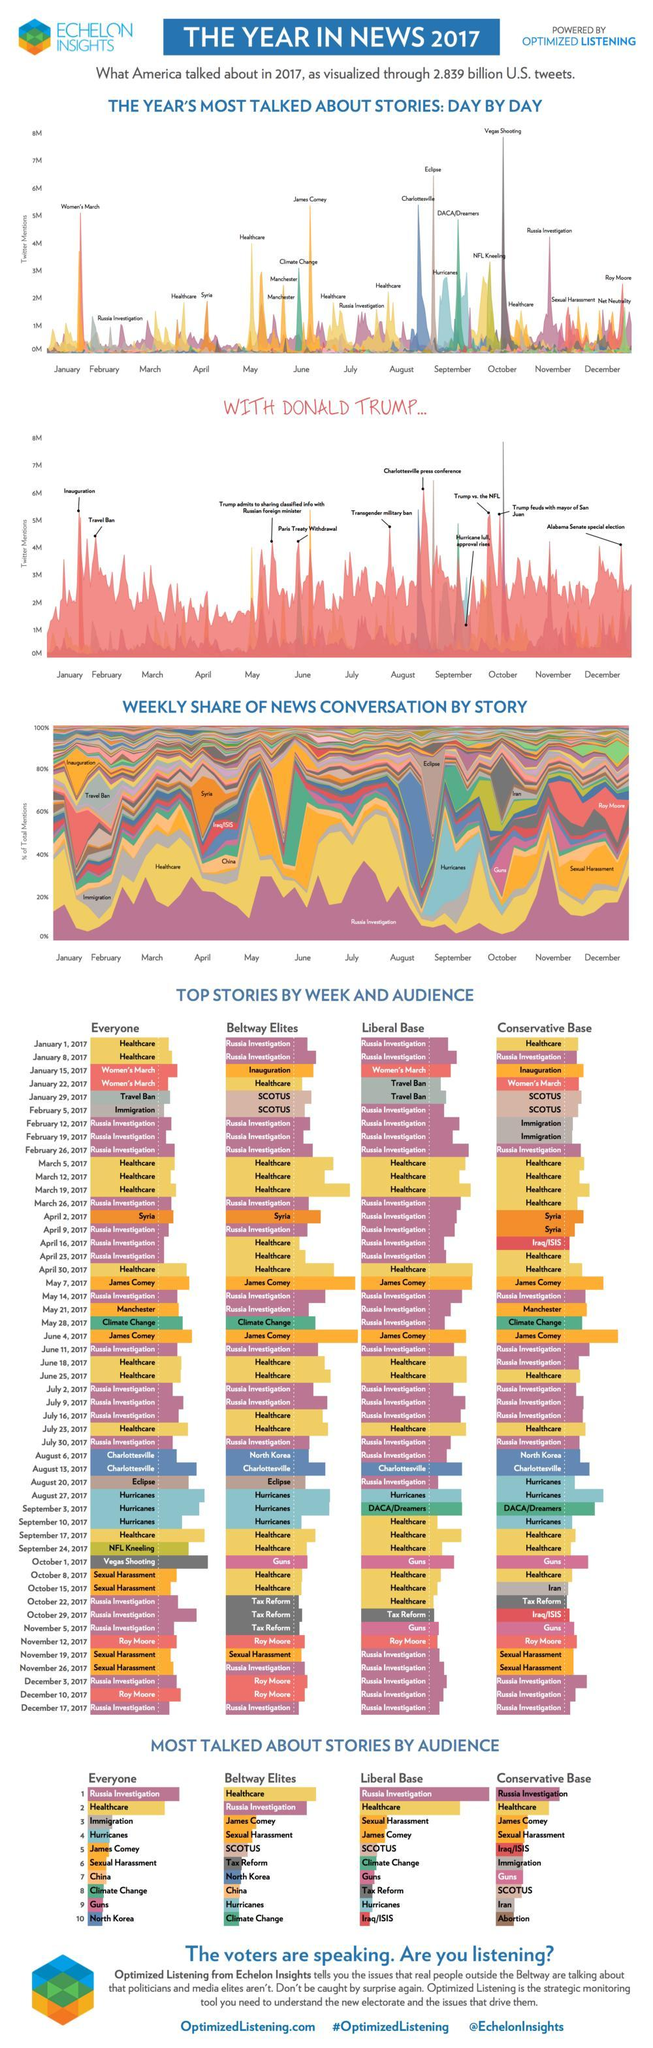During which month was Vegas shooting most talked about?
Answer the question with a short phrase. October Which was the most talked about story in November 2017? Russia Investigation 